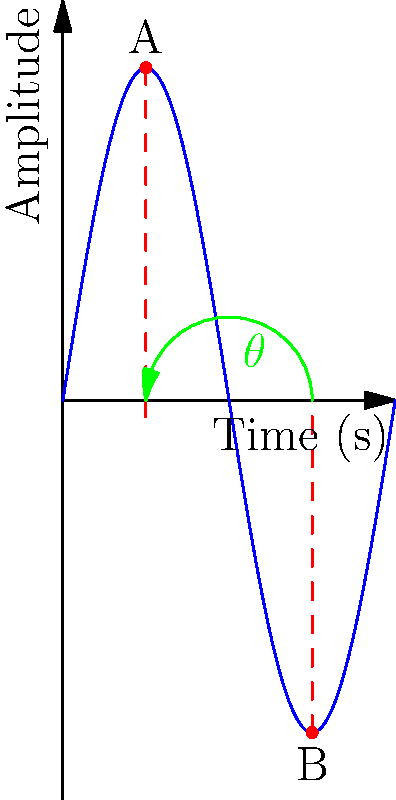In the sound wave diagram above, what is the angle $\theta$ (in degrees) between the positive peaks at points A and B? To find the angle $\theta$ between the positive peaks at points A and B, we need to follow these steps:

1. Recognize that the diagram shows one complete cycle of a sine wave.
2. Understand that one complete cycle corresponds to 360°.
3. Observe that points A and B are exactly half a cycle apart.
4. Calculate the angle:
   - Half a cycle = 360° ÷ 2
   - $\theta = 180°$

As a vocalist, understanding this concept can help you visualize how your voice's pitch changes over time in a recording. The sound engineer uses this type of visualization to analyze and enhance your vocal performance.
Answer: 180° 